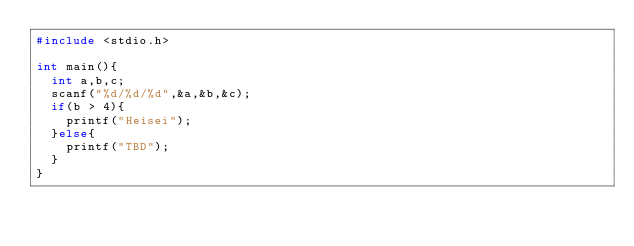Convert code to text. <code><loc_0><loc_0><loc_500><loc_500><_C_>#include <stdio.h>

int main(){
  int a,b,c;
  scanf("%d/%d/%d",&a,&b,&c);
  if(b > 4){
    printf("Heisei");
  }else{
    printf("TBD");
  }
}</code> 